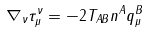Convert formula to latex. <formula><loc_0><loc_0><loc_500><loc_500>\nabla _ { \nu } \tau _ { \mu } ^ { \nu } = - 2 T _ { A B } n ^ { A } q _ { \mu } ^ { B }</formula> 